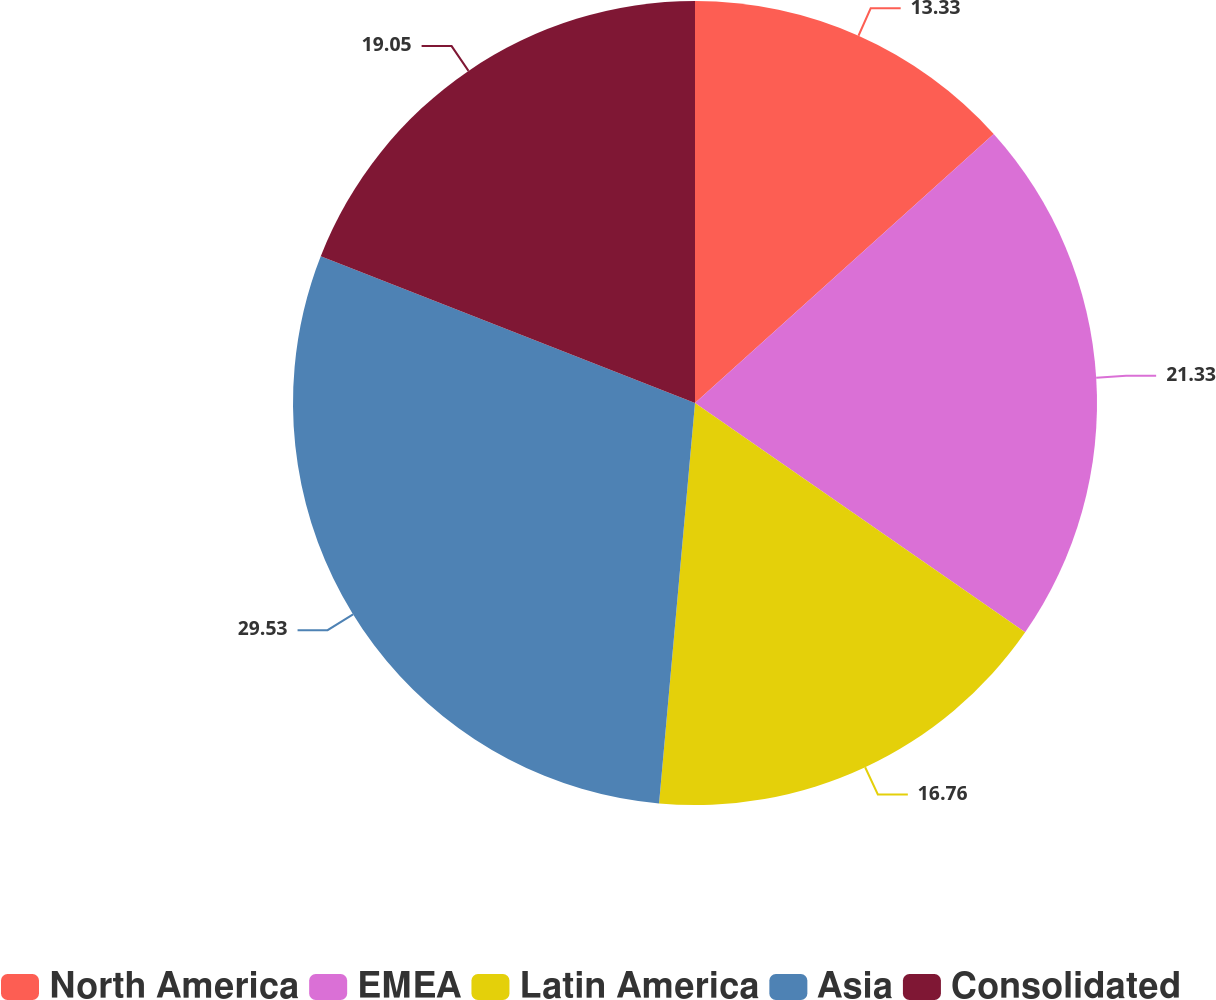Convert chart to OTSL. <chart><loc_0><loc_0><loc_500><loc_500><pie_chart><fcel>North America<fcel>EMEA<fcel>Latin America<fcel>Asia<fcel>Consolidated<nl><fcel>13.33%<fcel>21.33%<fcel>16.76%<fcel>29.52%<fcel>19.05%<nl></chart> 